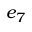Convert formula to latex. <formula><loc_0><loc_0><loc_500><loc_500>e _ { 7 }</formula> 